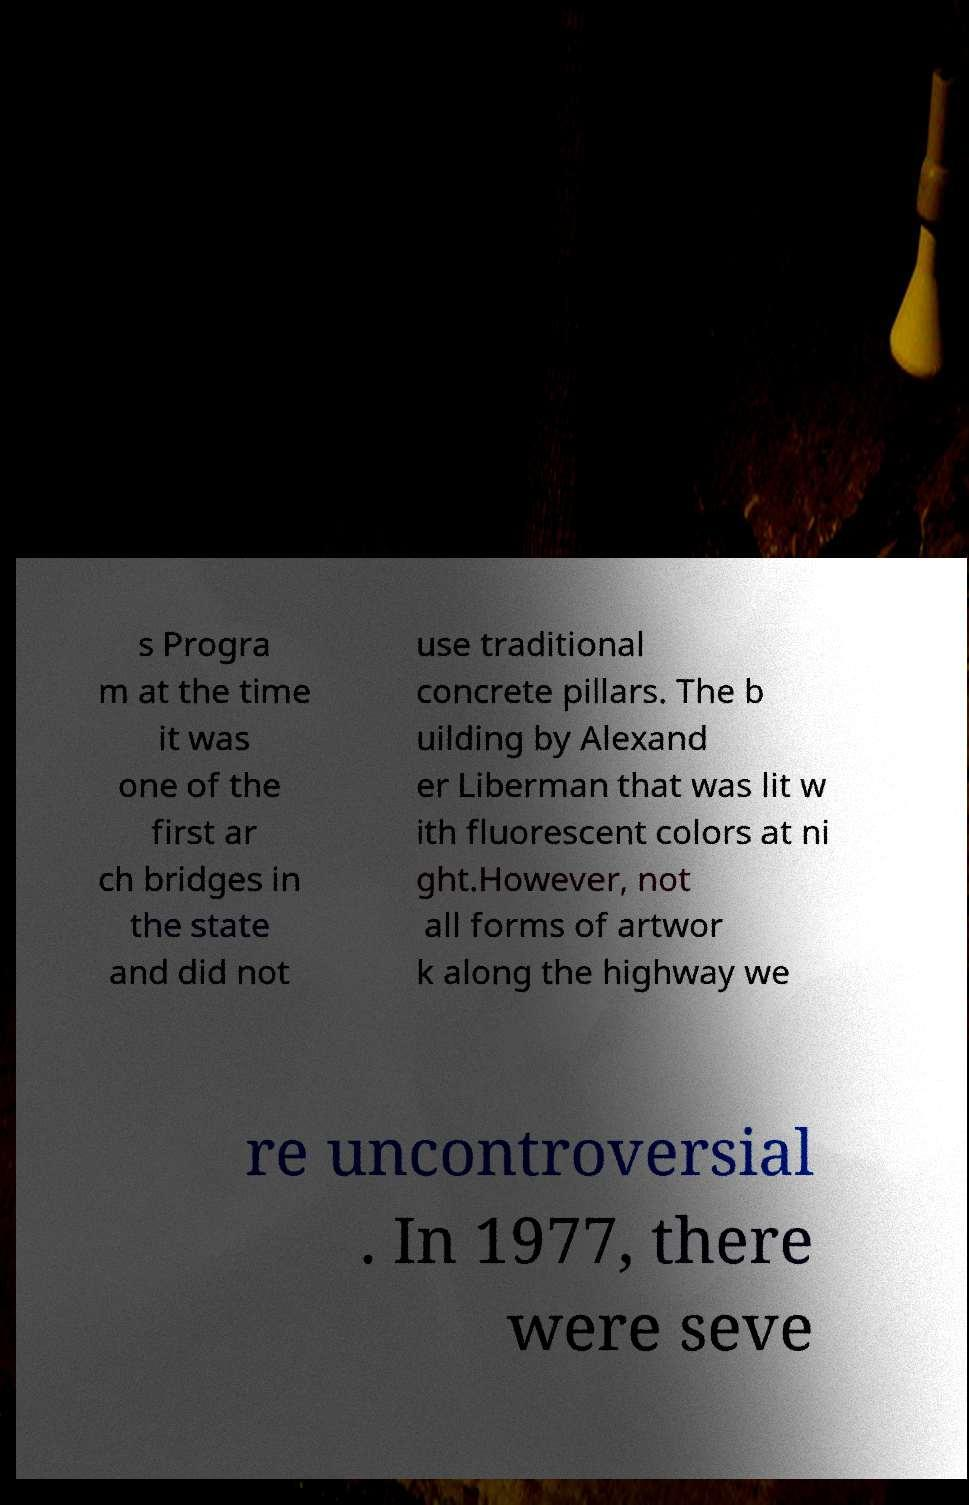Could you assist in decoding the text presented in this image and type it out clearly? s Progra m at the time it was one of the first ar ch bridges in the state and did not use traditional concrete pillars. The b uilding by Alexand er Liberman that was lit w ith fluorescent colors at ni ght.However, not all forms of artwor k along the highway we re uncontroversial . In 1977, there were seve 